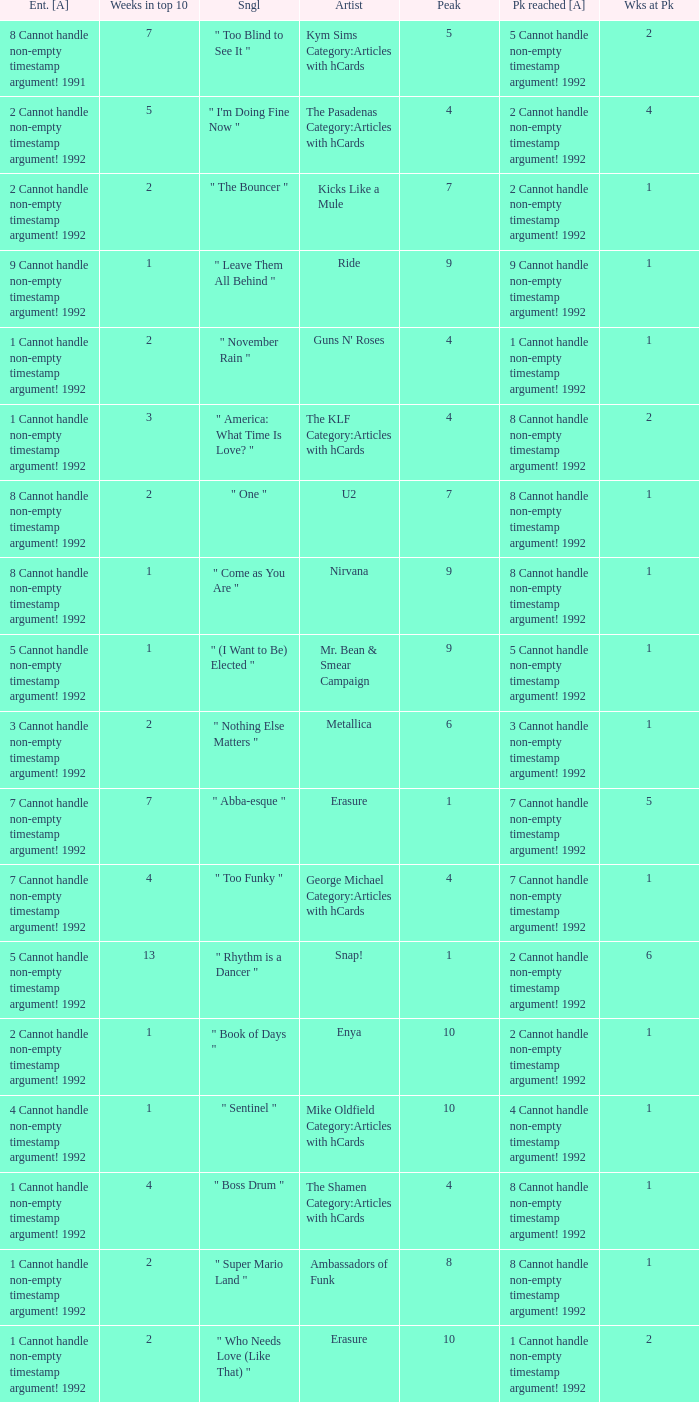What was the peak reached for a single with 4 weeks in the top 10 and entered in 7 cannot handle non-empty timestamp argument! 1992? 7 Cannot handle non-empty timestamp argument! 1992. 